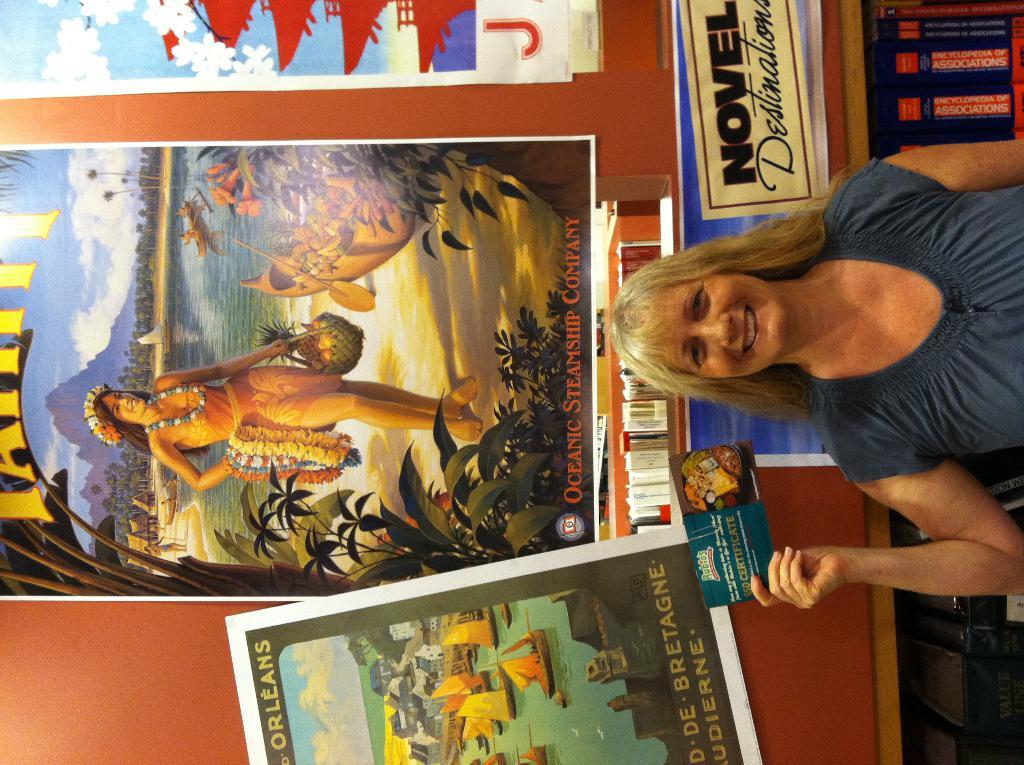<image>
Summarize the visual content of the image. A woman holds a postcard in front of a display about novel destinations. 